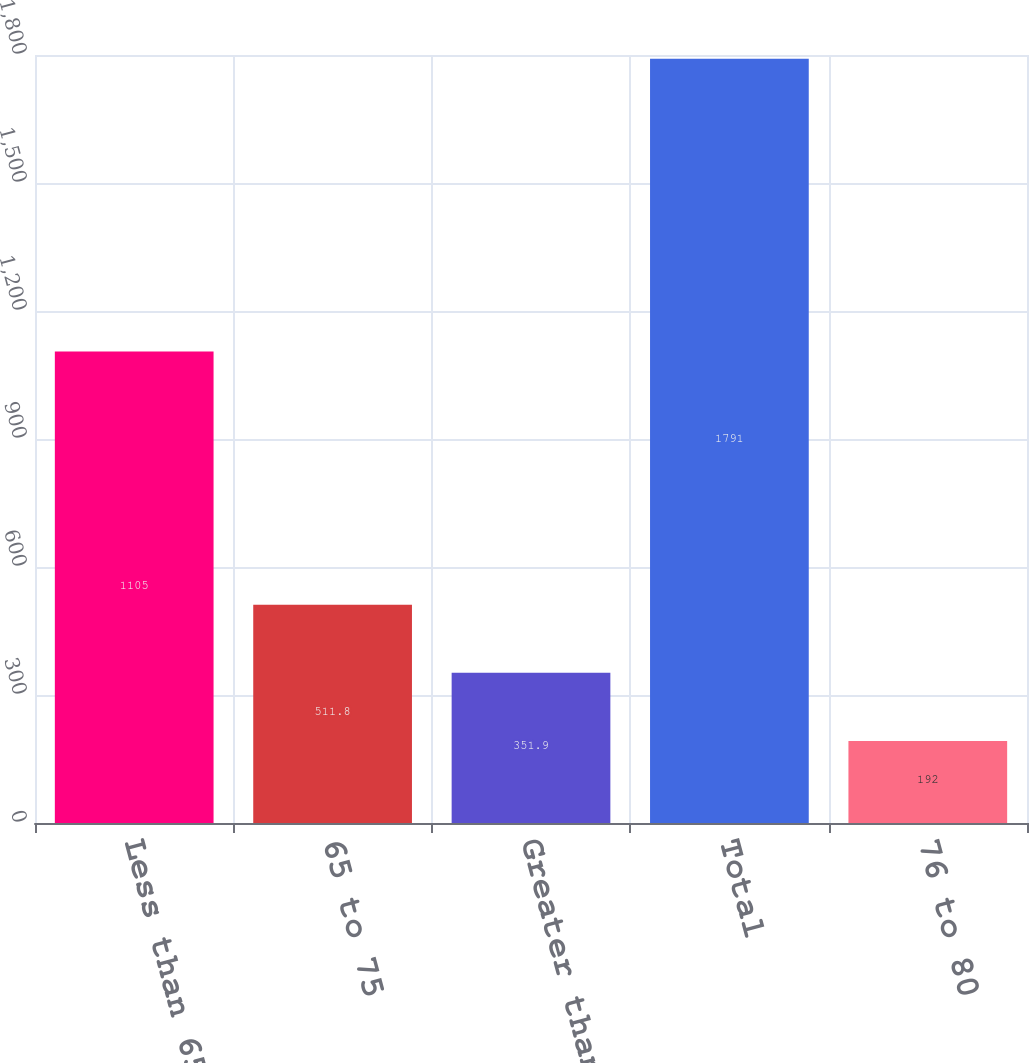Convert chart. <chart><loc_0><loc_0><loc_500><loc_500><bar_chart><fcel>Less than 65<fcel>65 to 75<fcel>Greater than 80<fcel>Total<fcel>76 to 80<nl><fcel>1105<fcel>511.8<fcel>351.9<fcel>1791<fcel>192<nl></chart> 